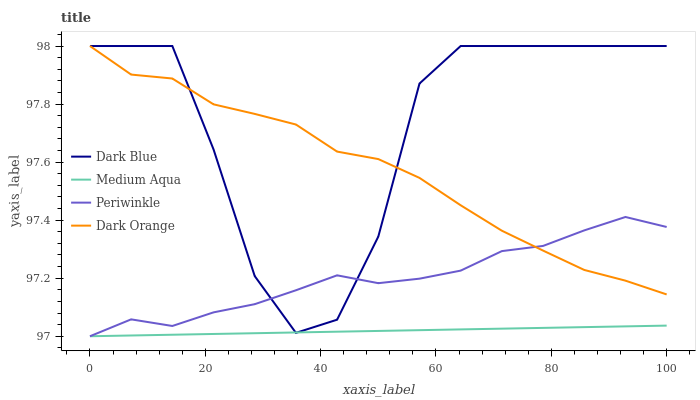Does Periwinkle have the minimum area under the curve?
Answer yes or no. No. Does Periwinkle have the maximum area under the curve?
Answer yes or no. No. Is Periwinkle the smoothest?
Answer yes or no. No. Is Periwinkle the roughest?
Answer yes or no. No. Does Dark Orange have the lowest value?
Answer yes or no. No. Does Periwinkle have the highest value?
Answer yes or no. No. Is Medium Aqua less than Dark Orange?
Answer yes or no. Yes. Is Dark Orange greater than Medium Aqua?
Answer yes or no. Yes. Does Medium Aqua intersect Dark Orange?
Answer yes or no. No. 